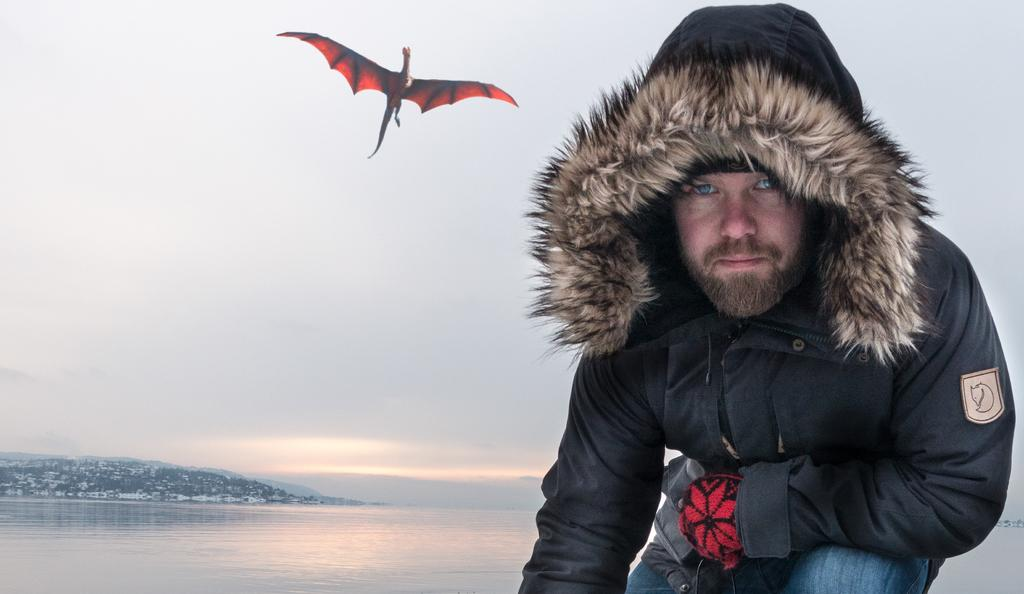Who is present in the image? There is a man in the image. What is located on the left side of the image? There is water on the left side of the image. What mythical creature is in the image? There is a dragon in the image. What is visible at the top of the image? The sky is visible at the top of the image. What type of yarn is the dragon using to fly in the image? There is no yarn present in the image, and the dragon is not shown flying. 